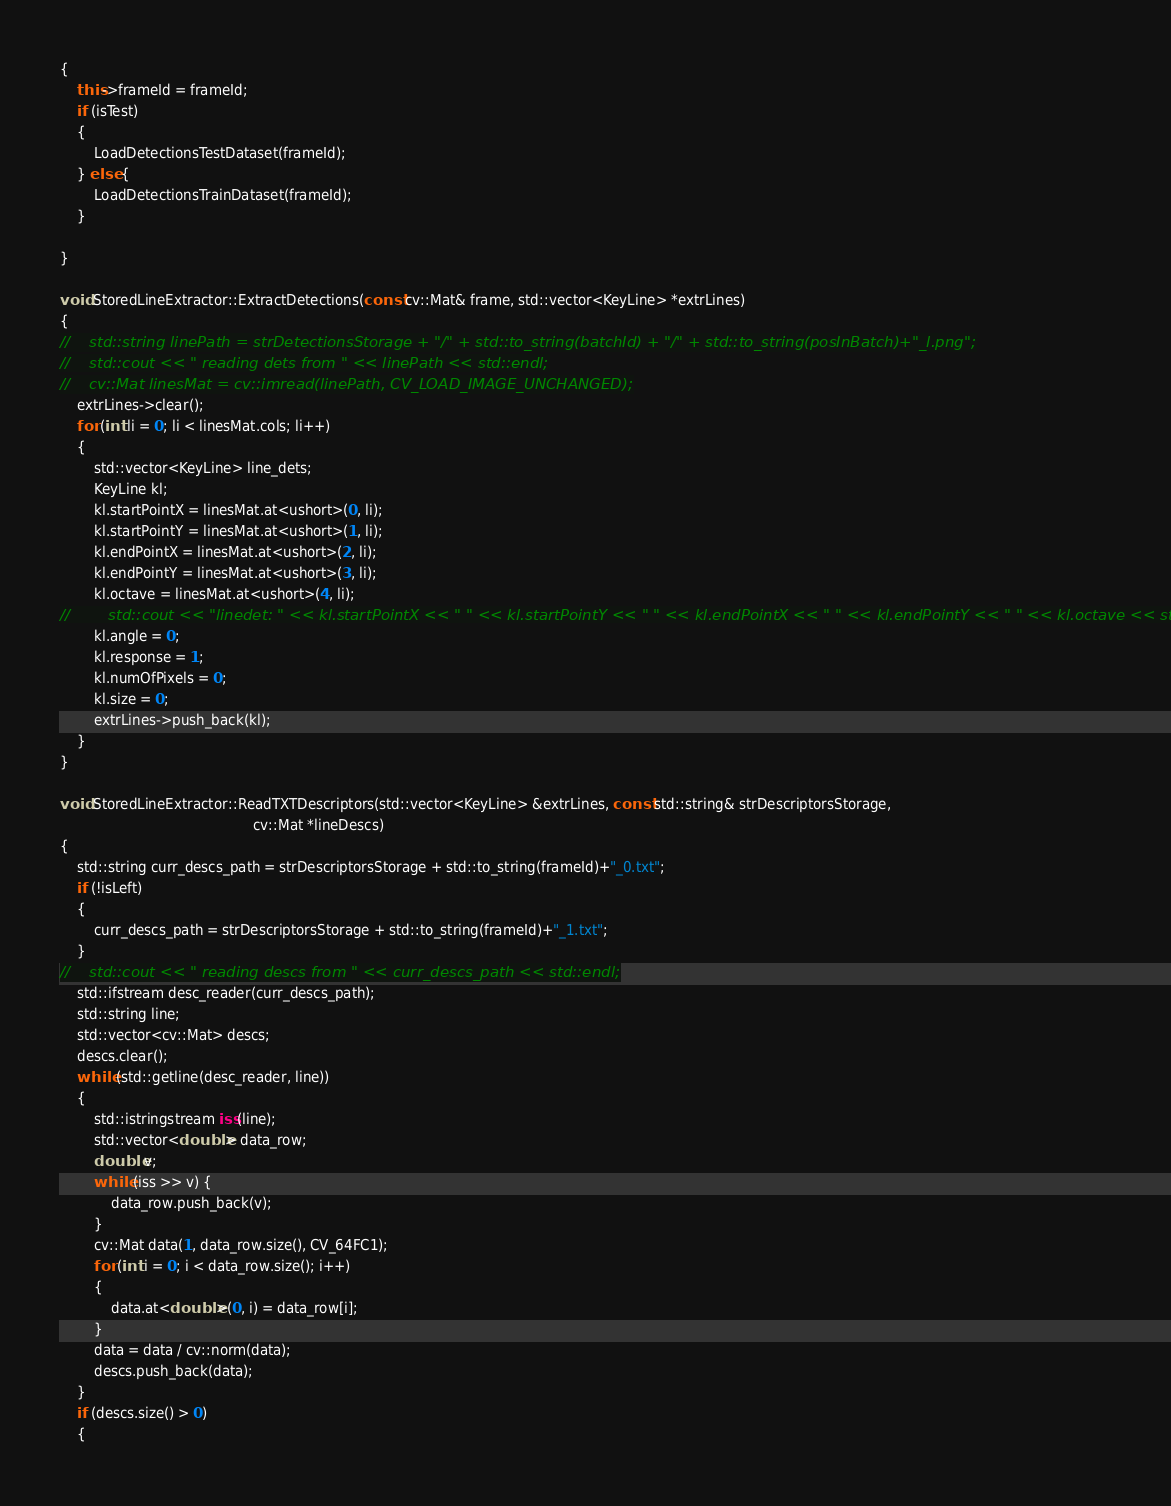Convert code to text. <code><loc_0><loc_0><loc_500><loc_500><_C++_>{
    this->frameId = frameId;
    if (isTest)
    {
        LoadDetectionsTestDataset(frameId);
    } else {
        LoadDetectionsTrainDataset(frameId);
    }

}

void StoredLineExtractor::ExtractDetections(const cv::Mat& frame, std::vector<KeyLine> *extrLines)
{
//    std::string linePath = strDetectionsStorage + "/" + std::to_string(batchId) + "/" + std::to_string(posInBatch)+"_l.png";
//    std::cout << " reading dets from " << linePath << std::endl;
//    cv::Mat linesMat = cv::imread(linePath, CV_LOAD_IMAGE_UNCHANGED);
    extrLines->clear();
    for (int li = 0; li < linesMat.cols; li++)
    {
        std::vector<KeyLine> line_dets;
        KeyLine kl;
        kl.startPointX = linesMat.at<ushort>(0, li);
        kl.startPointY = linesMat.at<ushort>(1, li);
        kl.endPointX = linesMat.at<ushort>(2, li);
        kl.endPointY = linesMat.at<ushort>(3, li);
        kl.octave = linesMat.at<ushort>(4, li);
//        std::cout << "linedet: " << kl.startPointX << " " << kl.startPointY << " " << kl.endPointX << " " << kl.endPointY << " " << kl.octave << std::endl;
        kl.angle = 0;
        kl.response = 1;
        kl.numOfPixels = 0;
        kl.size = 0;
        extrLines->push_back(kl);
    }
}

void StoredLineExtractor::ReadTXTDescriptors(std::vector<KeyLine> &extrLines, const std::string& strDescriptorsStorage,
                                             cv::Mat *lineDescs)
{
    std::string curr_descs_path = strDescriptorsStorage + std::to_string(frameId)+"_0.txt";
    if (!isLeft)
    {
        curr_descs_path = strDescriptorsStorage + std::to_string(frameId)+"_1.txt";
    }
//    std::cout << " reading descs from " << curr_descs_path << std::endl;
    std::ifstream desc_reader(curr_descs_path);
    std::string line;
    std::vector<cv::Mat> descs;
    descs.clear();
    while (std::getline(desc_reader, line))
    {
        std::istringstream iss(line);
        std::vector<double> data_row;
        double v;
        while (iss >> v) {
            data_row.push_back(v);
        }
        cv::Mat data(1, data_row.size(), CV_64FC1);
        for (int i = 0; i < data_row.size(); i++)
        {
            data.at<double>(0, i) = data_row[i];
        }
        data = data / cv::norm(data);
        descs.push_back(data);
    }
    if (descs.size() > 0)
    {</code> 